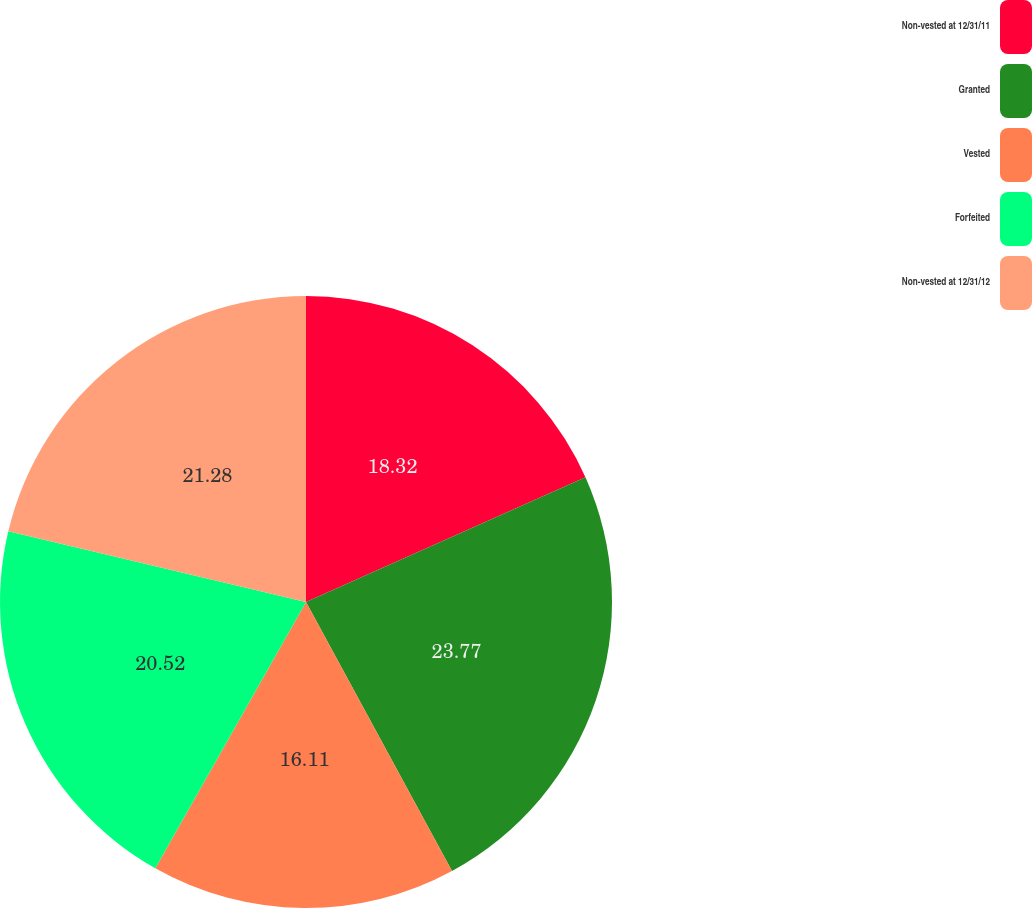<chart> <loc_0><loc_0><loc_500><loc_500><pie_chart><fcel>Non-vested at 12/31/11<fcel>Granted<fcel>Vested<fcel>Forfeited<fcel>Non-vested at 12/31/12<nl><fcel>18.32%<fcel>23.76%<fcel>16.11%<fcel>20.52%<fcel>21.28%<nl></chart> 